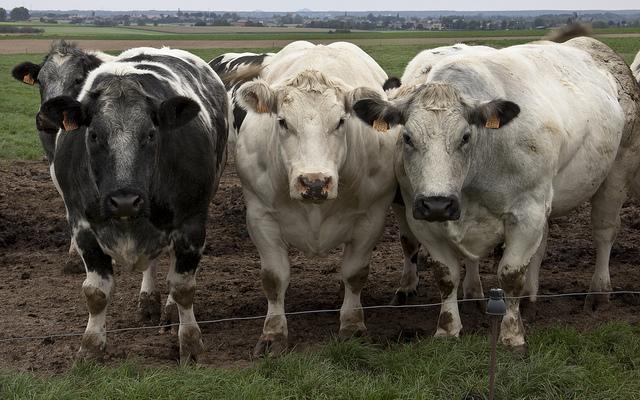How many cows are there?
Give a very brief answer. 4. How many chairs are there?
Give a very brief answer. 0. 